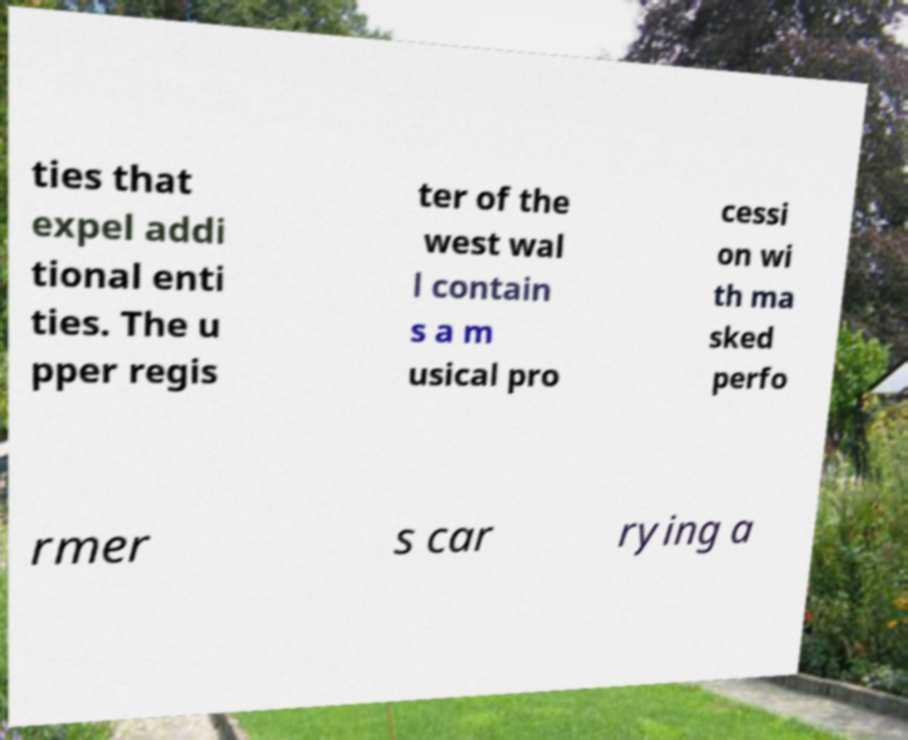Can you accurately transcribe the text from the provided image for me? ties that expel addi tional enti ties. The u pper regis ter of the west wal l contain s a m usical pro cessi on wi th ma sked perfo rmer s car rying a 